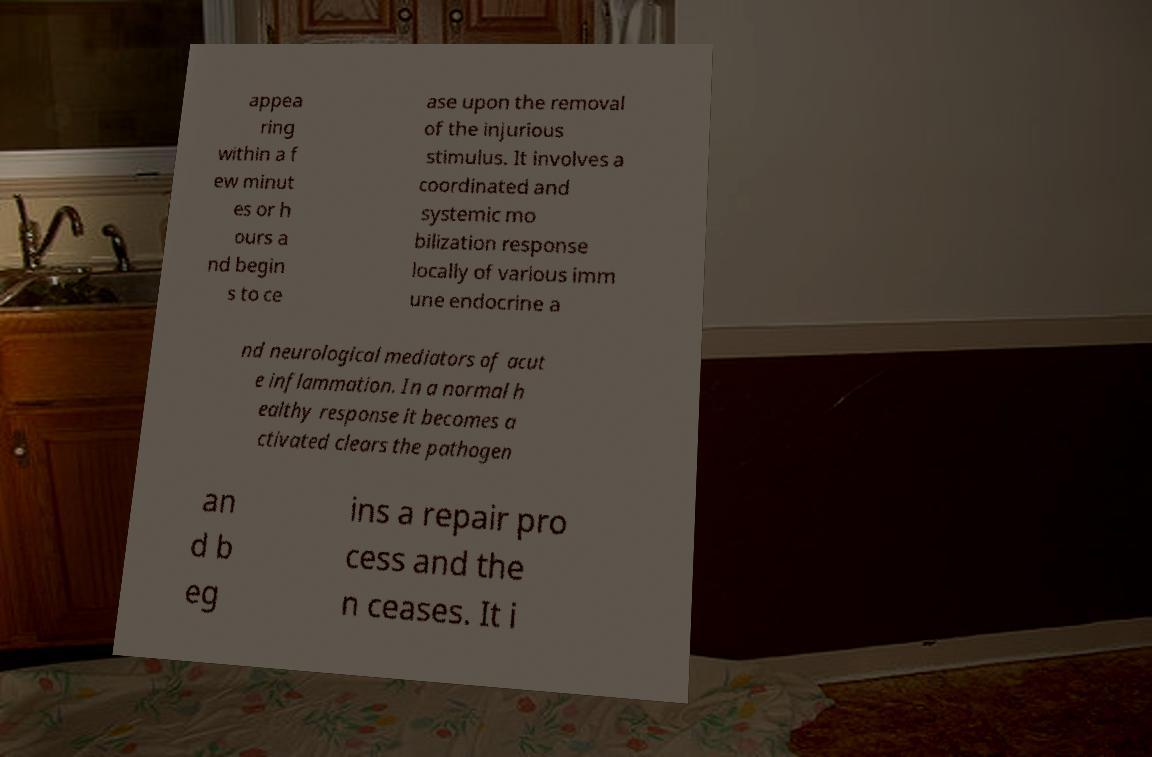What messages or text are displayed in this image? I need them in a readable, typed format. appea ring within a f ew minut es or h ours a nd begin s to ce ase upon the removal of the injurious stimulus. It involves a coordinated and systemic mo bilization response locally of various imm une endocrine a nd neurological mediators of acut e inflammation. In a normal h ealthy response it becomes a ctivated clears the pathogen an d b eg ins a repair pro cess and the n ceases. It i 